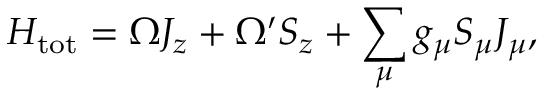Convert formula to latex. <formula><loc_0><loc_0><loc_500><loc_500>H _ { t o t } = \Omega J _ { z } + \Omega ^ { \prime } S _ { z } + \sum _ { \mu } g _ { \mu } S _ { \mu } J _ { \mu } ,</formula> 